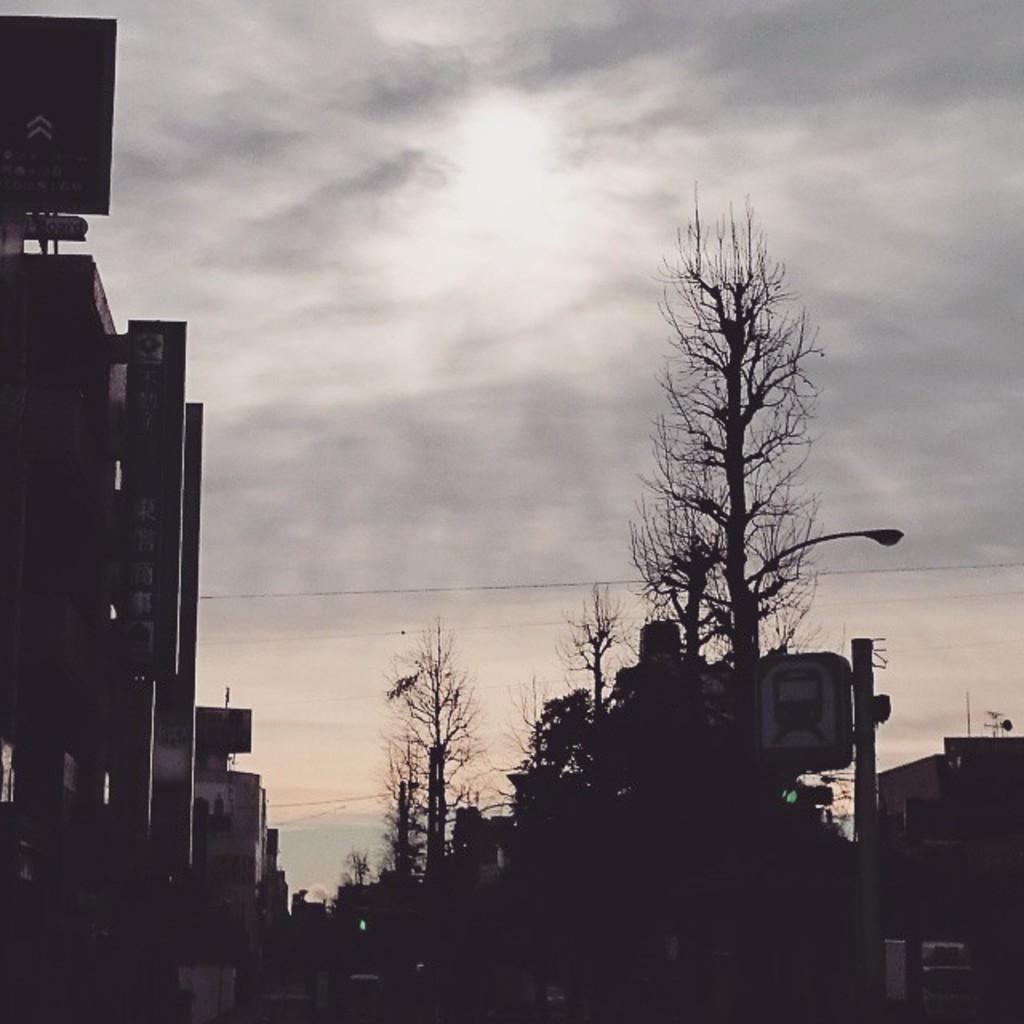What type of structures can be seen in the image? There are buildings in the image. What other objects are present in the image? There are boards, trees, and a pole in the image. What can be seen in the background of the image? The sky is visible in the background of the image. Can you see a needle being used to sew a connection between the buildings in the image? There is no needle or any sewing activity depicted in the image. 